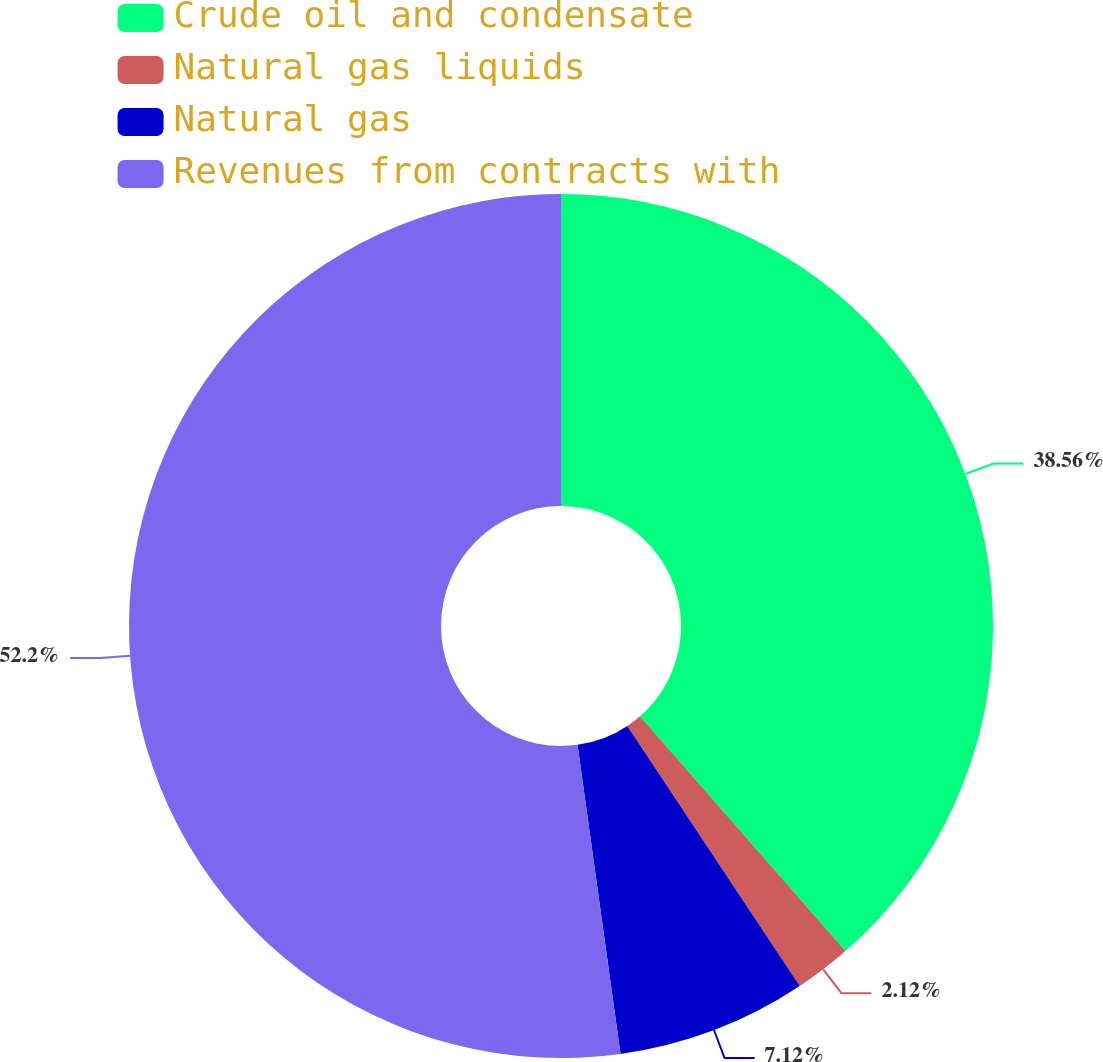Convert chart. <chart><loc_0><loc_0><loc_500><loc_500><pie_chart><fcel>Crude oil and condensate<fcel>Natural gas liquids<fcel>Natural gas<fcel>Revenues from contracts with<nl><fcel>38.56%<fcel>2.12%<fcel>7.12%<fcel>52.2%<nl></chart> 